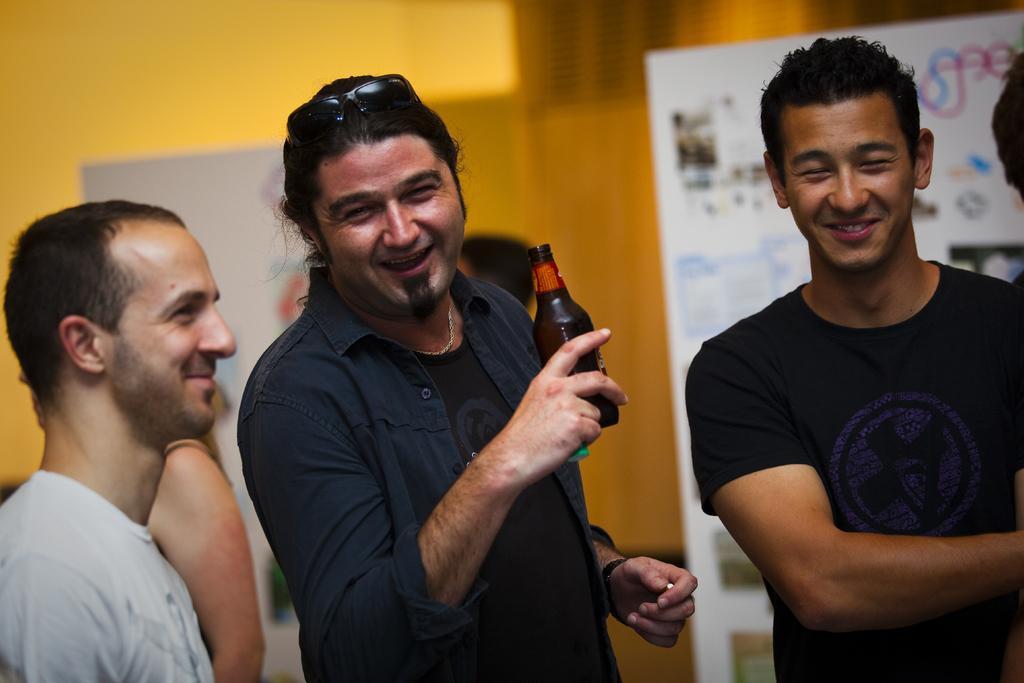Could you give a brief overview of what you see in this image? There are three persons standing. In the middle a person is wearing goggles and holding a bottle. In the background there is a banner and a yellow wall is there. 